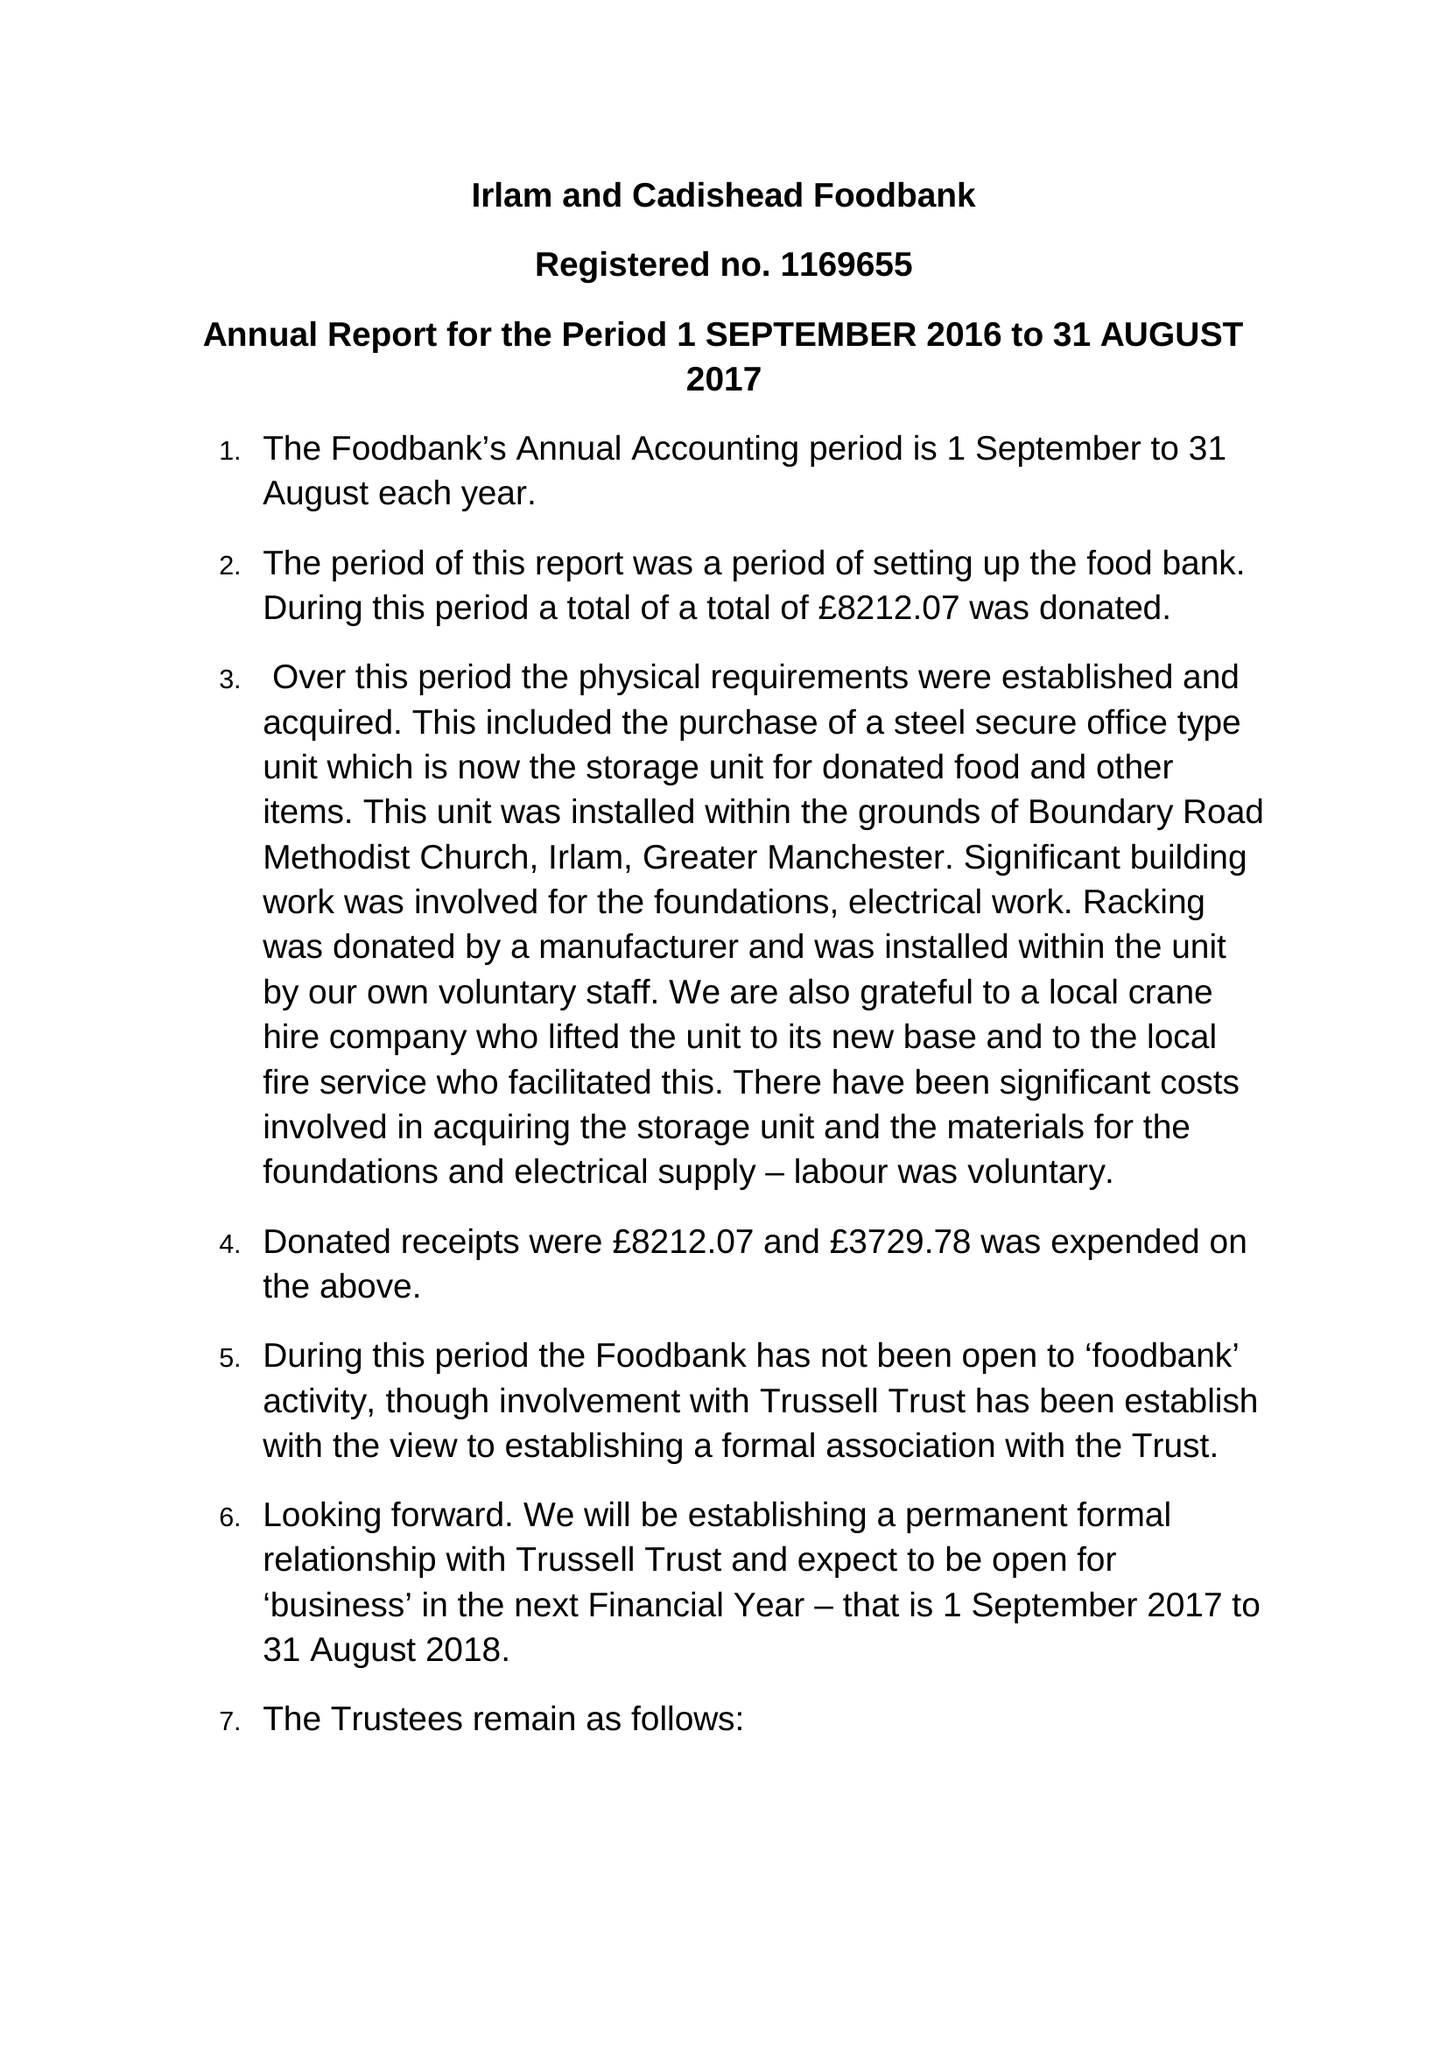What is the value for the report_date?
Answer the question using a single word or phrase. 2017-08-31 